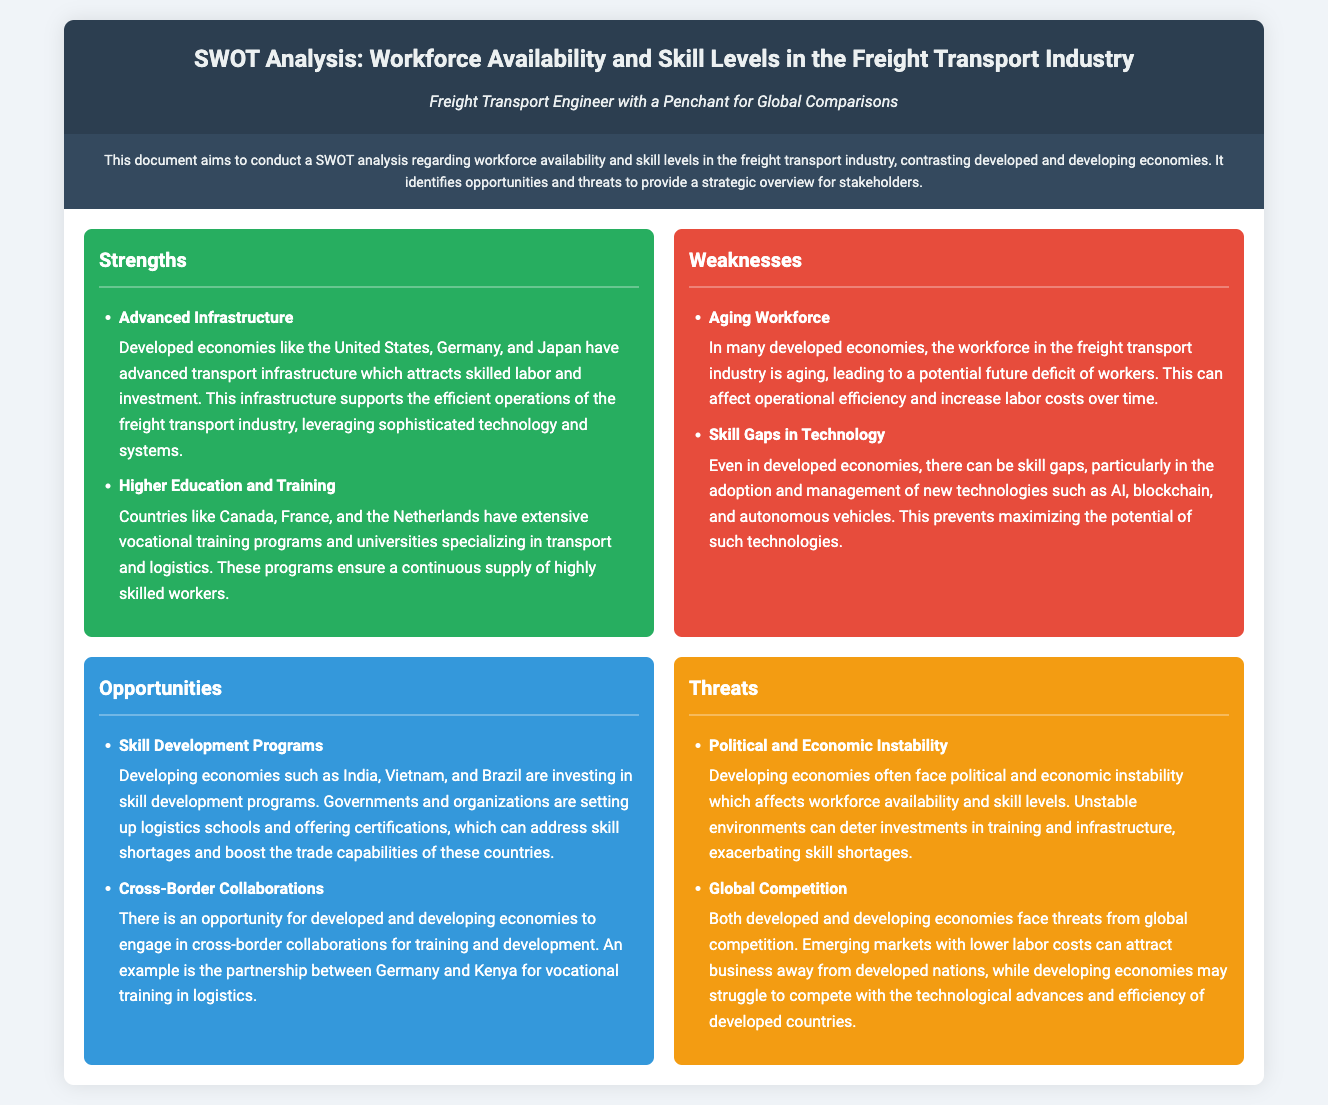What are the strengths of developed economies in the freight transport industry? The strengths of developed economies in the freight transport industry include advanced infrastructure and higher education and training programs.
Answer: Advanced Infrastructure, Higher Education and Training What is a weakness indicated for developed economies? A weakness indicated for developed economies is their aging workforce, which can lead to future labor shortages.
Answer: Aging Workforce Which countries are investing in skill development programs according to the document? The document mentions developing economies such as India, Vietnam, and Brazil as investing in skill development programs.
Answer: India, Vietnam, Brazil What opportunity for collaboration is mentioned in the document? The document highlights cross-border collaborations for training and development, specifically mentioning a partnership between Germany and Kenya.
Answer: Cross-Border Collaborations What is a threat faced by developing economies in the freight transport industry? The document states that political and economic instability is a significant threat faced by developing economies, affecting workforce availability.
Answer: Political and Economic Instability What type of educational programs do developed countries like Canada and France have? The document mentions that developed countries like Canada and France have extensive vocational training programs and universities specializing in transport and logistics.
Answer: Vocational training programs Which technological skill gap affects developed economies? The skill gap mentioned for developed economies is in the adoption and management of new technologies like AI, blockchain, and autonomous vehicles.
Answer: Skill Gaps in Technology What is a challenge for developing economies regarding global competition? Developing economies struggle to compete with the technological advances and efficiency presented by developed countries, as stated in the document.
Answer: Technological advances and efficiency What demographic issue is affecting the efficiency of freight transport operations in developed economies? The aging workforce in developed economies is affecting operational efficiency, as highlighted in the document.
Answer: Aging Workforce 